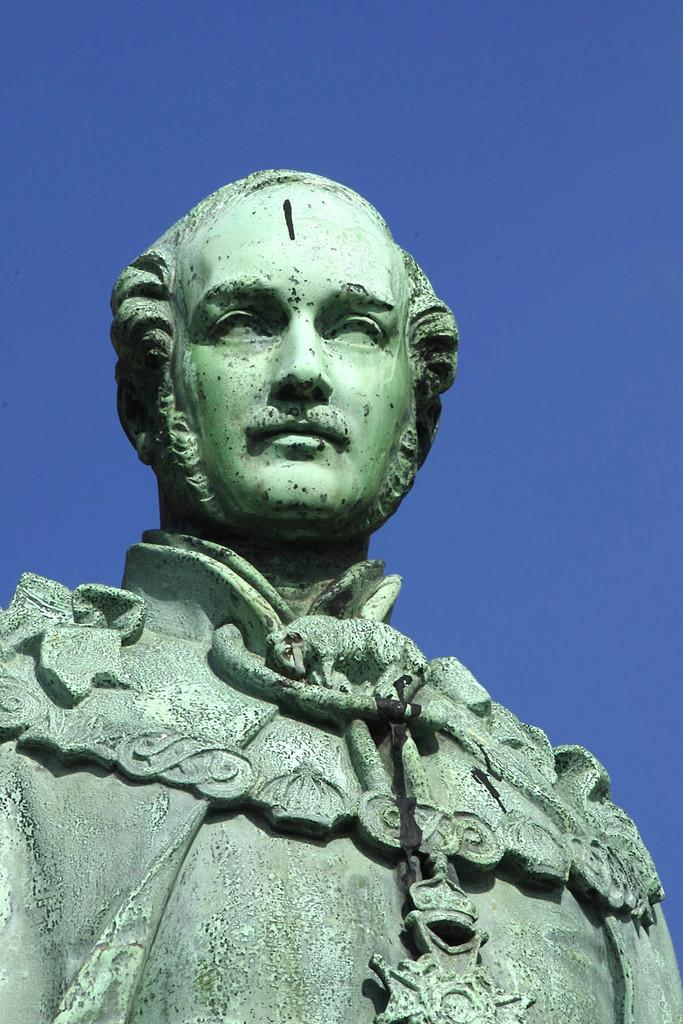What is the main subject of the image? There is a sculpture of a person in the image. What can be seen in the background of the image? The sky is visible in the background of the image. What is the color of the sky in the image? The color of the sky is blue. How many dolls are sitting on the box in the image? There is no box or dolls present in the image. 